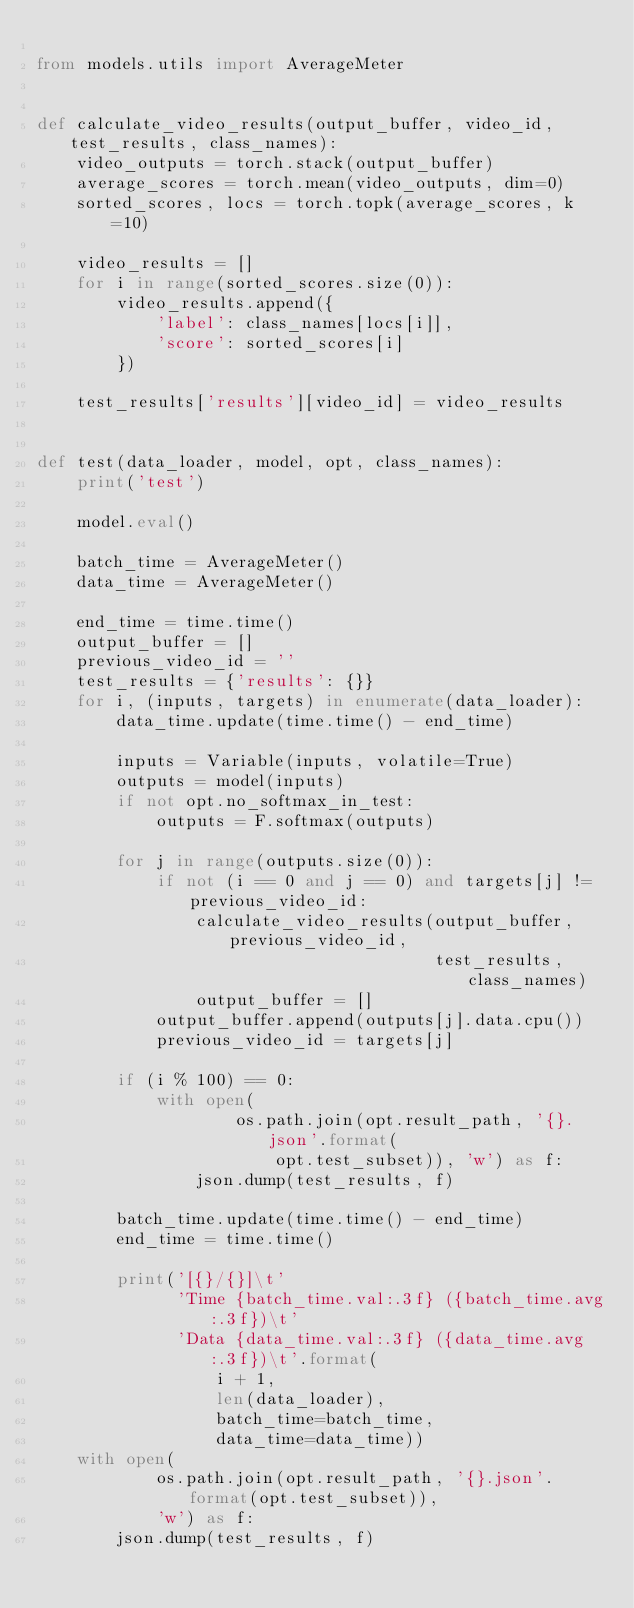Convert code to text. <code><loc_0><loc_0><loc_500><loc_500><_Python_>
from models.utils import AverageMeter


def calculate_video_results(output_buffer, video_id, test_results, class_names):
    video_outputs = torch.stack(output_buffer)
    average_scores = torch.mean(video_outputs, dim=0)
    sorted_scores, locs = torch.topk(average_scores, k=10)

    video_results = []
    for i in range(sorted_scores.size(0)):
        video_results.append({
            'label': class_names[locs[i]],
            'score': sorted_scores[i]
        })

    test_results['results'][video_id] = video_results


def test(data_loader, model, opt, class_names):
    print('test')

    model.eval()

    batch_time = AverageMeter()
    data_time = AverageMeter()

    end_time = time.time()
    output_buffer = []
    previous_video_id = ''
    test_results = {'results': {}}
    for i, (inputs, targets) in enumerate(data_loader):
        data_time.update(time.time() - end_time)

        inputs = Variable(inputs, volatile=True)
        outputs = model(inputs)
        if not opt.no_softmax_in_test:
            outputs = F.softmax(outputs)

        for j in range(outputs.size(0)):
            if not (i == 0 and j == 0) and targets[j] != previous_video_id:
                calculate_video_results(output_buffer, previous_video_id,
                                        test_results, class_names)
                output_buffer = []
            output_buffer.append(outputs[j].data.cpu())
            previous_video_id = targets[j]

        if (i % 100) == 0:
            with open(
                    os.path.join(opt.result_path, '{}.json'.format(
                        opt.test_subset)), 'w') as f:
                json.dump(test_results, f)

        batch_time.update(time.time() - end_time)
        end_time = time.time()

        print('[{}/{}]\t'
              'Time {batch_time.val:.3f} ({batch_time.avg:.3f})\t'
              'Data {data_time.val:.3f} ({data_time.avg:.3f})\t'.format(
                  i + 1,
                  len(data_loader),
                  batch_time=batch_time,
                  data_time=data_time))
    with open(
            os.path.join(opt.result_path, '{}.json'.format(opt.test_subset)),
            'w') as f:
        json.dump(test_results, f)
</code> 